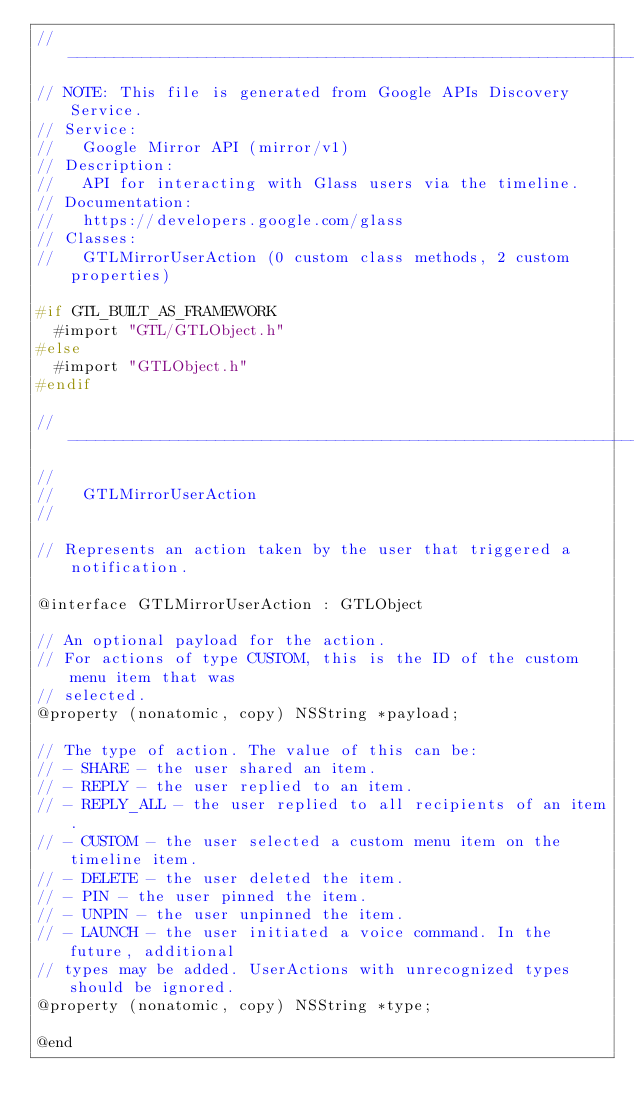<code> <loc_0><loc_0><loc_500><loc_500><_C_>// ----------------------------------------------------------------------------
// NOTE: This file is generated from Google APIs Discovery Service.
// Service:
//   Google Mirror API (mirror/v1)
// Description:
//   API for interacting with Glass users via the timeline.
// Documentation:
//   https://developers.google.com/glass
// Classes:
//   GTLMirrorUserAction (0 custom class methods, 2 custom properties)

#if GTL_BUILT_AS_FRAMEWORK
  #import "GTL/GTLObject.h"
#else
  #import "GTLObject.h"
#endif

// ----------------------------------------------------------------------------
//
//   GTLMirrorUserAction
//

// Represents an action taken by the user that triggered a notification.

@interface GTLMirrorUserAction : GTLObject

// An optional payload for the action.
// For actions of type CUSTOM, this is the ID of the custom menu item that was
// selected.
@property (nonatomic, copy) NSString *payload;

// The type of action. The value of this can be:
// - SHARE - the user shared an item.
// - REPLY - the user replied to an item.
// - REPLY_ALL - the user replied to all recipients of an item.
// - CUSTOM - the user selected a custom menu item on the timeline item.
// - DELETE - the user deleted the item.
// - PIN - the user pinned the item.
// - UNPIN - the user unpinned the item.
// - LAUNCH - the user initiated a voice command. In the future, additional
// types may be added. UserActions with unrecognized types should be ignored.
@property (nonatomic, copy) NSString *type;

@end
</code> 